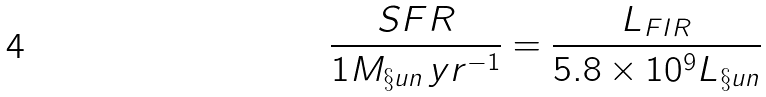Convert formula to latex. <formula><loc_0><loc_0><loc_500><loc_500>\frac { S F R } { 1 M _ { \S u n } \, y r ^ { - 1 } } = \frac { L _ { F I R } } { 5 . 8 \times 1 0 ^ { 9 } L _ { \S u n } }</formula> 